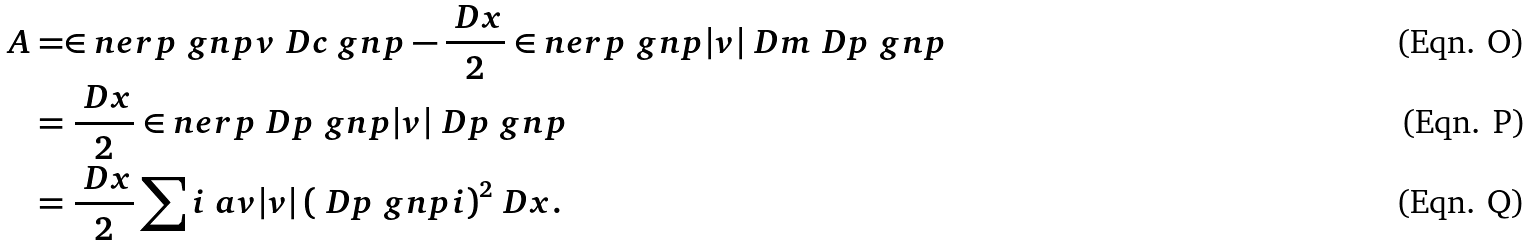Convert formula to latex. <formula><loc_0><loc_0><loc_500><loc_500>A & = \in n e r p { \ g n p } { v \ D c \ g n p } - \frac { \ D x } { 2 } \in n e r p { \ g n p } { | v | \ D m \ D p \ g n p } \\ & = \frac { \ D x } { 2 } \in n e r p { \ D p \ g n p } { | v | \ D p \ g n p } \\ & = \frac { \ D x } { 2 } \sum i \ a v { | v | \left ( \ D p \ g n p i \right ) ^ { 2 } } \ D x .</formula> 